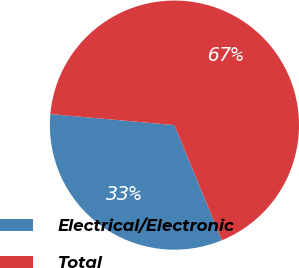Convert chart. <chart><loc_0><loc_0><loc_500><loc_500><pie_chart><fcel>Electrical/Electronic<fcel>Total<nl><fcel>32.63%<fcel>67.37%<nl></chart> 